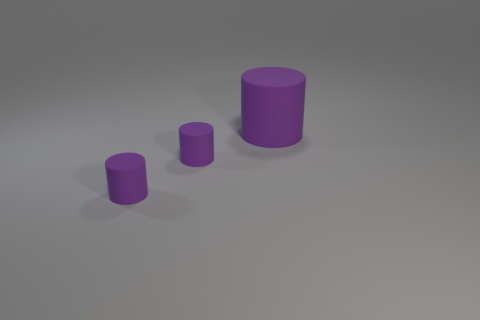Subtract all purple cylinders. How many were subtracted if there are1purple cylinders left? 2 Subtract all small cylinders. How many cylinders are left? 1 Add 2 cyan rubber spheres. How many objects exist? 5 Subtract 0 cyan blocks. How many objects are left? 3 Subtract all gray cylinders. Subtract all gray blocks. How many cylinders are left? 3 Subtract all green cubes. How many blue cylinders are left? 0 Subtract all large cyan metal cylinders. Subtract all purple cylinders. How many objects are left? 0 Add 3 matte cylinders. How many matte cylinders are left? 6 Add 2 tiny balls. How many tiny balls exist? 2 